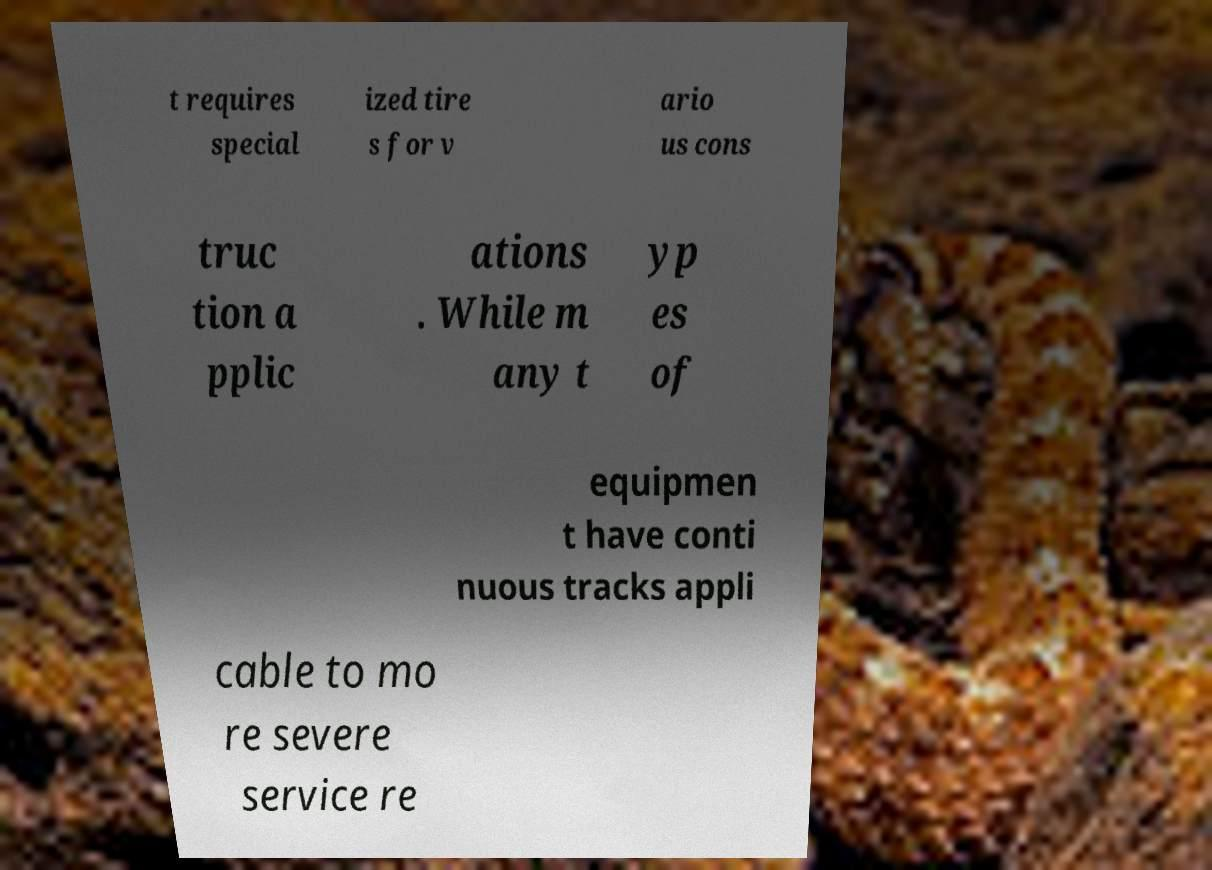What messages or text are displayed in this image? I need them in a readable, typed format. t requires special ized tire s for v ario us cons truc tion a pplic ations . While m any t yp es of equipmen t have conti nuous tracks appli cable to mo re severe service re 